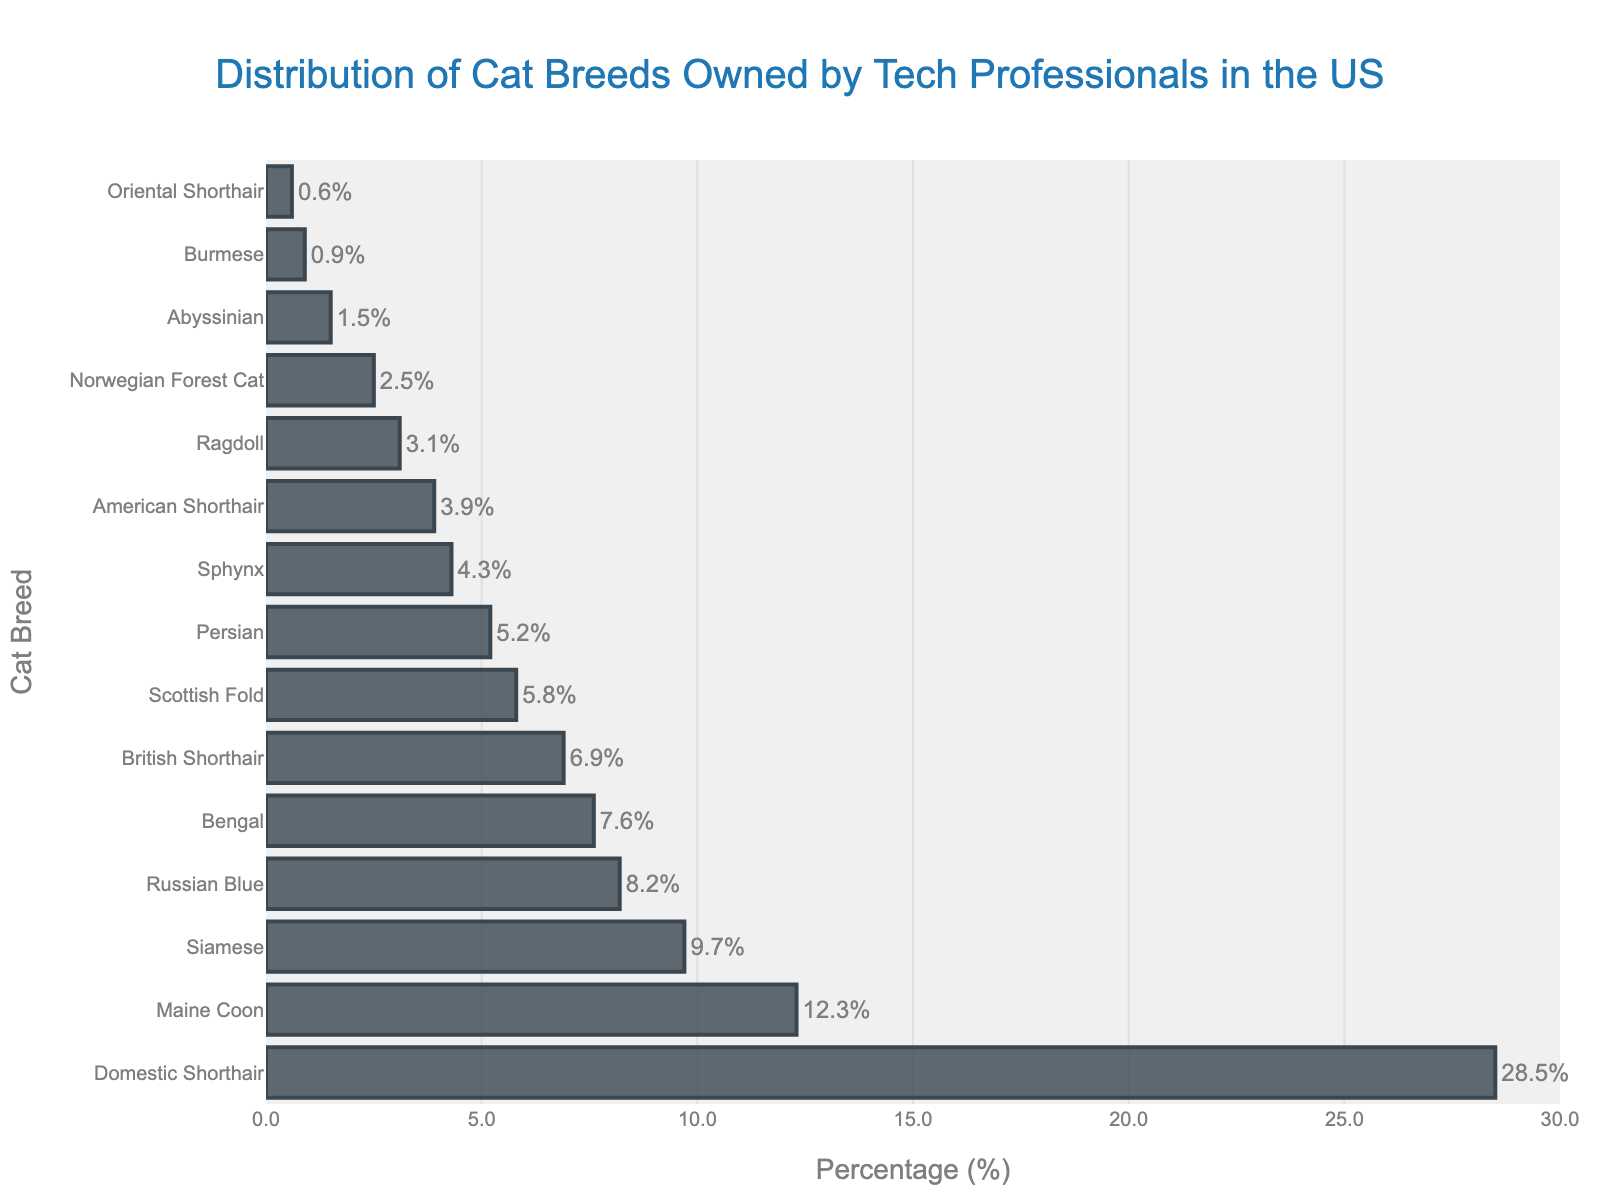Which cat breed is most commonly owned by tech professionals in the US? The highest bar represents the most commonly owned cat breed. The Domestic Shorthair breed has the highest bar at 28.5%.
Answer: Domestic Shorthair What is the percentage difference between Domestic Shorthair and Maine Coon cat breeds? Subtract the percentage of Maine Coon (12.3%) from the percentage of Domestic Shorthair (28.5%). The difference is 28.5% - 12.3% = 16.2%.
Answer: 16.2% Which cat breed has the smallest percentage ownership among tech professionals? The shortest bar corresponds to the least commonly owned cat breed. The Oriental Shorthair has the lowest bar at 0.6%.
Answer: Oriental Shorthair Combined, what percentage of tech professionals own either a Siamese or a Bengal cat? Add the percentages of the Siamese (9.7%) and Bengal (7.6%) breeds. The total is 9.7% + 7.6% = 17.3%.
Answer: 17.3% How does the percentage of Ragdoll cats compare to the percentage of Persian cats? Compare the percentages of Ragdoll (3.1%) and Persian (5.2%) breeds. Since 3.1% is less than 5.2%, Ragdoll is less common than Persian.
Answer: Ragdoll is less common than Persian Is the percentage of British Shorthair cat ownership greater than or less than 7%? Look at the bar for British Shorthair. It is at 6.9%, which is less than 7%.
Answer: Less than 7% What is the combined percentage of Domestic Shorthair, Maine Coon, and Siamese cat breeds? Add the percentages of Domestic Shorthair (28.5%), Maine Coon (12.3%), and Siamese (9.7%). The total is 28.5% + 12.3% + 9.7% = 50.5%.
Answer: 50.5% What is the average ownership percentage of the top five most common cat breeds? Sum the percentages of the top five breeds (Domestic Shorthair 28.5%, Maine Coon 12.3%, Siamese 9.7%, Russian Blue 8.2%, Bengal 7.6%) and divide by 5. The sum is 66.3%, so the average is 66.3% / 5 = 13.26%.
Answer: 13.3% Which breed has a higher ownership rate, Russian Blue or American Shorthair? Compare the bars for Russian Blue (8.2%) and American Shorthair (3.9%). Russian Blue has a higher percentage.
Answer: Russian Blue What is the total ownership percentage for all the cat breeds listed? Sum the percentages of all the breeds. Total = 28.5 + 12.3 + 9.7 + 8.2 + 7.6 + 6.9 + 5.8 + 5.2 + 4.3 + 3.9 + 3.1 + 2.5 + 1.5 + 0.9 + 0.6 = 100%.
Answer: 100% 